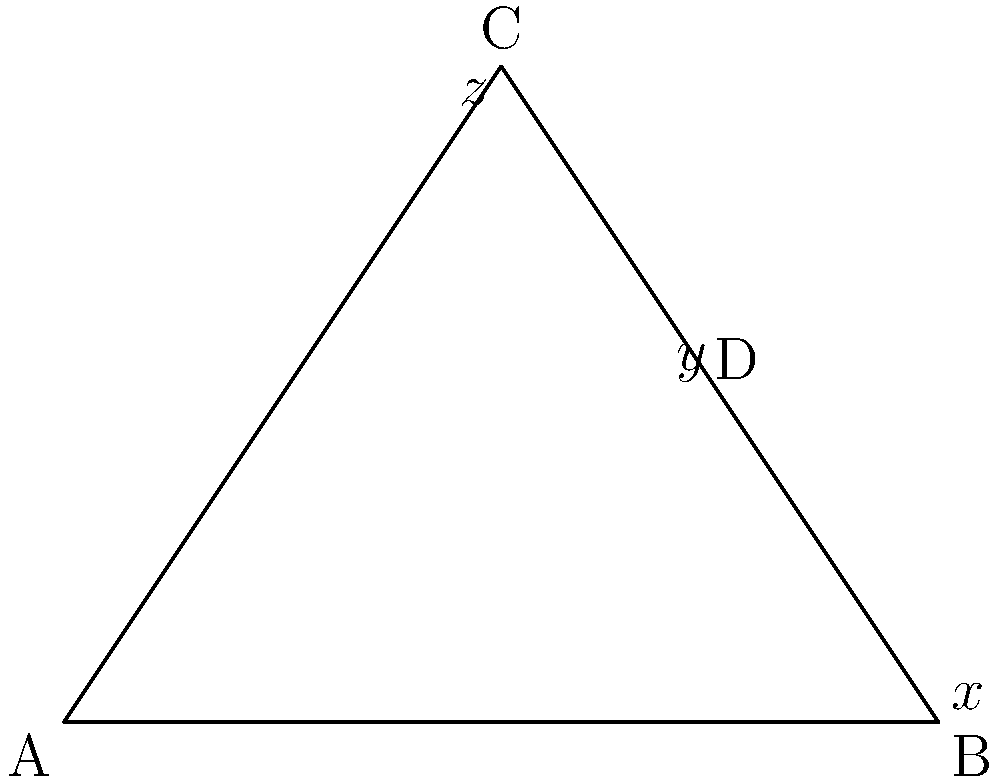During our bus ride to campus, we notice a triangle-shaped road sign. This reminds me of a geometry problem. In the triangle ABC shown, BD is an exterior angle. If the measures of the interior angles are $x°$, $y°$, and $z°$ as labeled, what is the measure of angle CBD in terms of $y$ and $z$? Let's approach this step-by-step:

1) First, recall the exterior angle theorem: An exterior angle of a triangle is equal to the sum of the two non-adjacent interior angles.

2) In this case, angle CBD is an exterior angle, and its non-adjacent interior angles are $y°$ and $z°$.

3) Therefore, we can write:
   $$\angle CBD = y° + z°$$

4) We don't need to use the value of $x°$ in this problem, but it's worth noting that in any triangle, the sum of interior angles is always 180°. So:
   $$x° + y° + z° = 180°$$

5) The measure of angle CBD can be expressed simply as $y° + z°$.
Answer: $y° + z°$ 